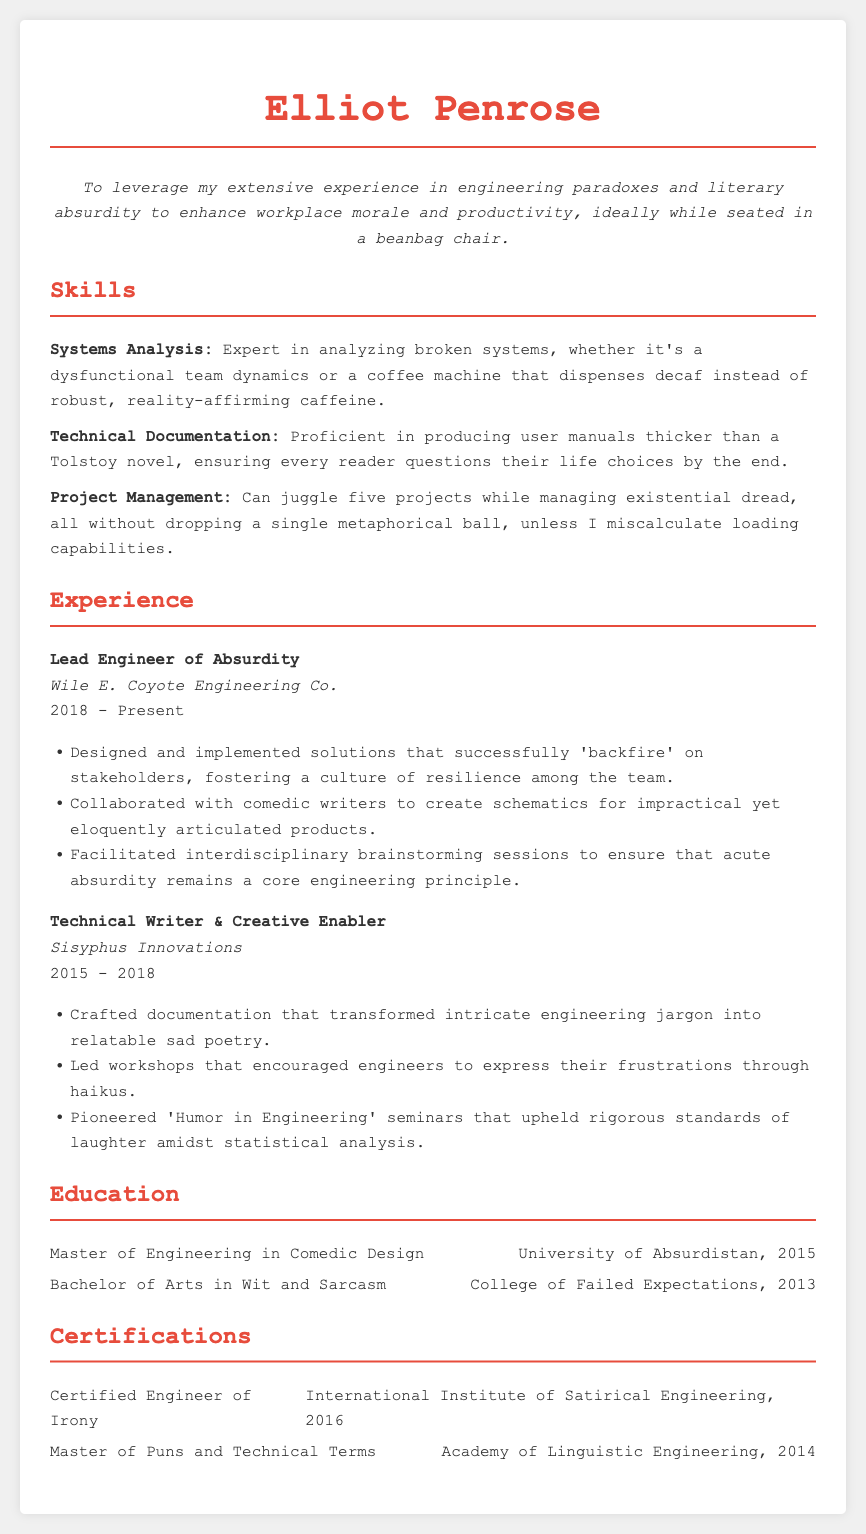What is the name of the person in the resume? The name of the person is presented prominently at the top of the resume.
Answer: Elliot Penrose What is the objective stated in the resume? The objective statement provides insight into the individual's career goals and preferences regarding workplace atmosphere.
Answer: To leverage my extensive experience in engineering paradoxes and literary absurdity to enhance workplace morale and productivity, ideally while seated in a beanbag chair What is Elliot's job title at Wile E. Coyote Engineering Co.? The job titles are outlined in the experience section of the resume, indicating current and past roles.
Answer: Lead Engineer of Absurdity In what year did Elliot Penrose graduate with a Master of Engineering in Comedic Design? Education achievements are listed with corresponding degrees and years, which indicate the timeline of Elliot's qualifications.
Answer: 2015 How many years did Elliot work at Sisyphus Innovations? The dates in the experience section can be used to quantify the duration of employment at each company.
Answer: 3 years 